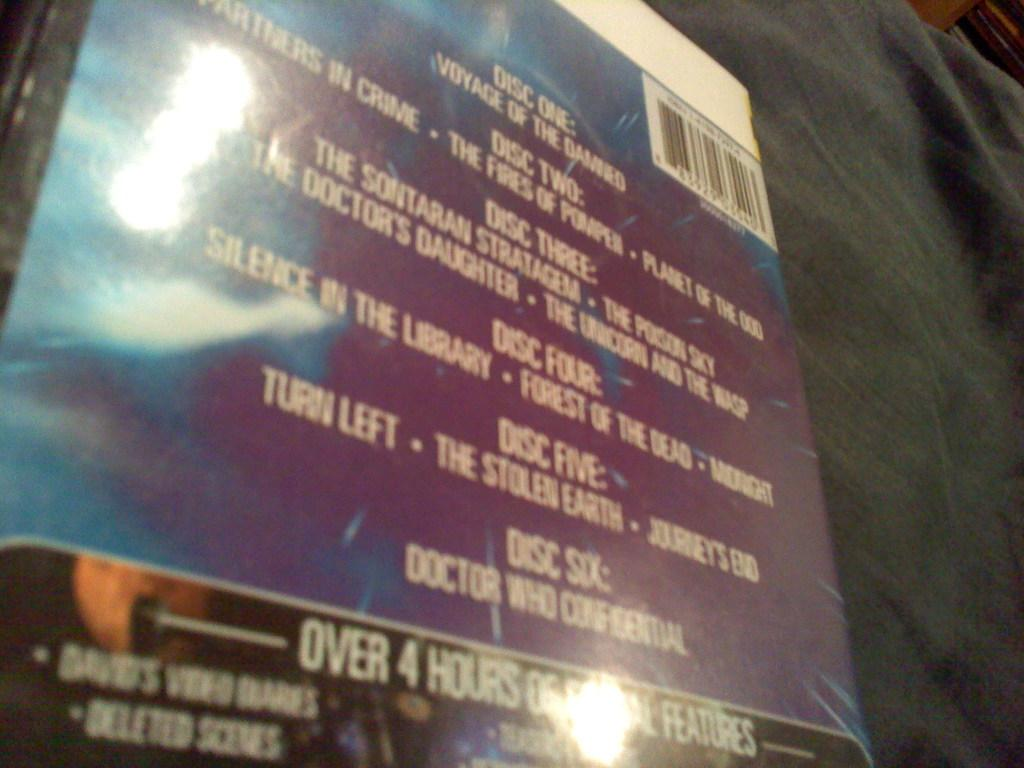Provide a one-sentence caption for the provided image. The back of a CD box displays the contents on each of the six discs. 